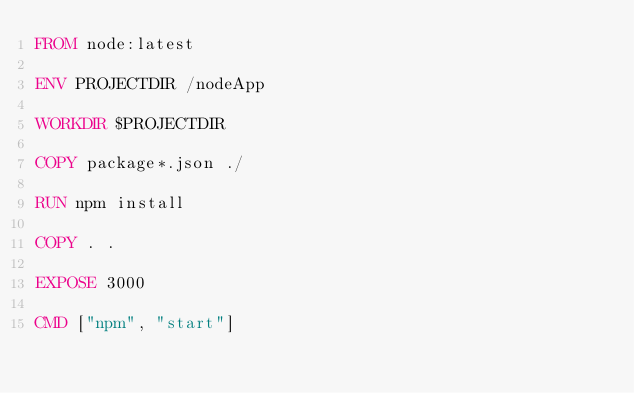Convert code to text. <code><loc_0><loc_0><loc_500><loc_500><_Dockerfile_>FROM node:latest

ENV PROJECTDIR /nodeApp

WORKDIR $PROJECTDIR

COPY package*.json ./

RUN npm install

COPY . .

EXPOSE 3000

CMD ["npm", "start"]</code> 